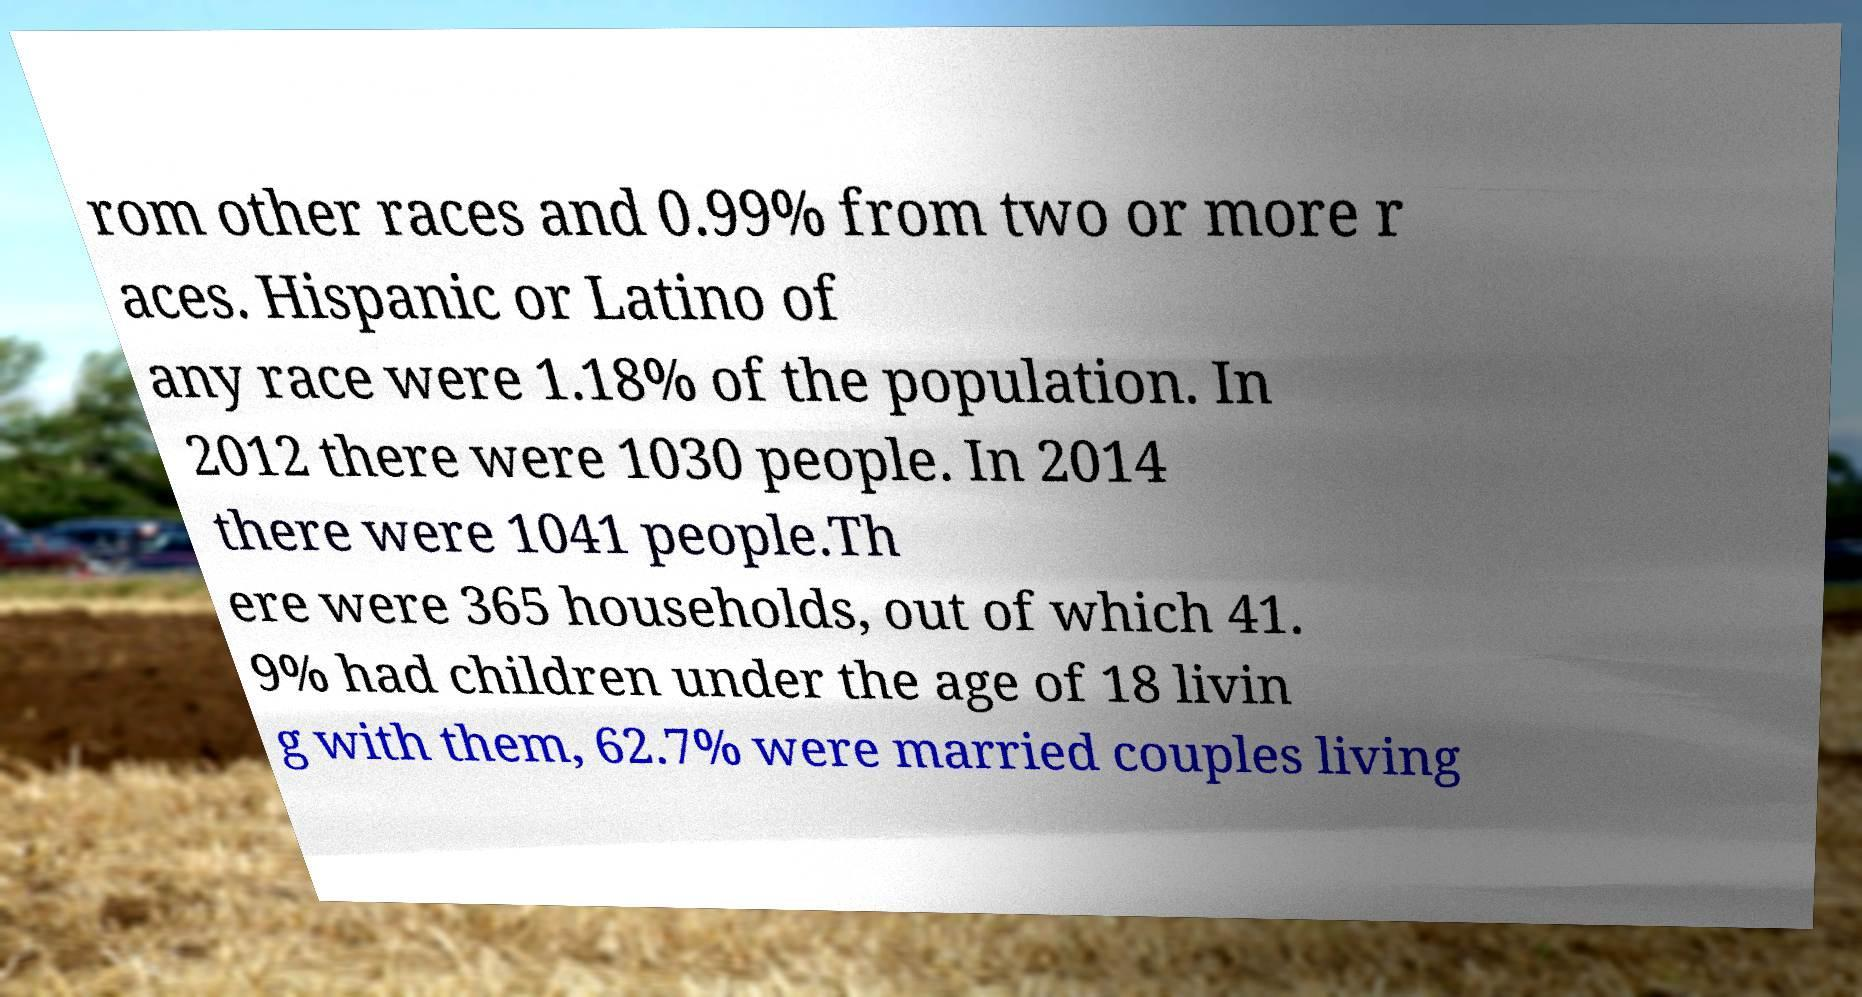For documentation purposes, I need the text within this image transcribed. Could you provide that? rom other races and 0.99% from two or more r aces. Hispanic or Latino of any race were 1.18% of the population. In 2012 there were 1030 people. In 2014 there were 1041 people.Th ere were 365 households, out of which 41. 9% had children under the age of 18 livin g with them, 62.7% were married couples living 